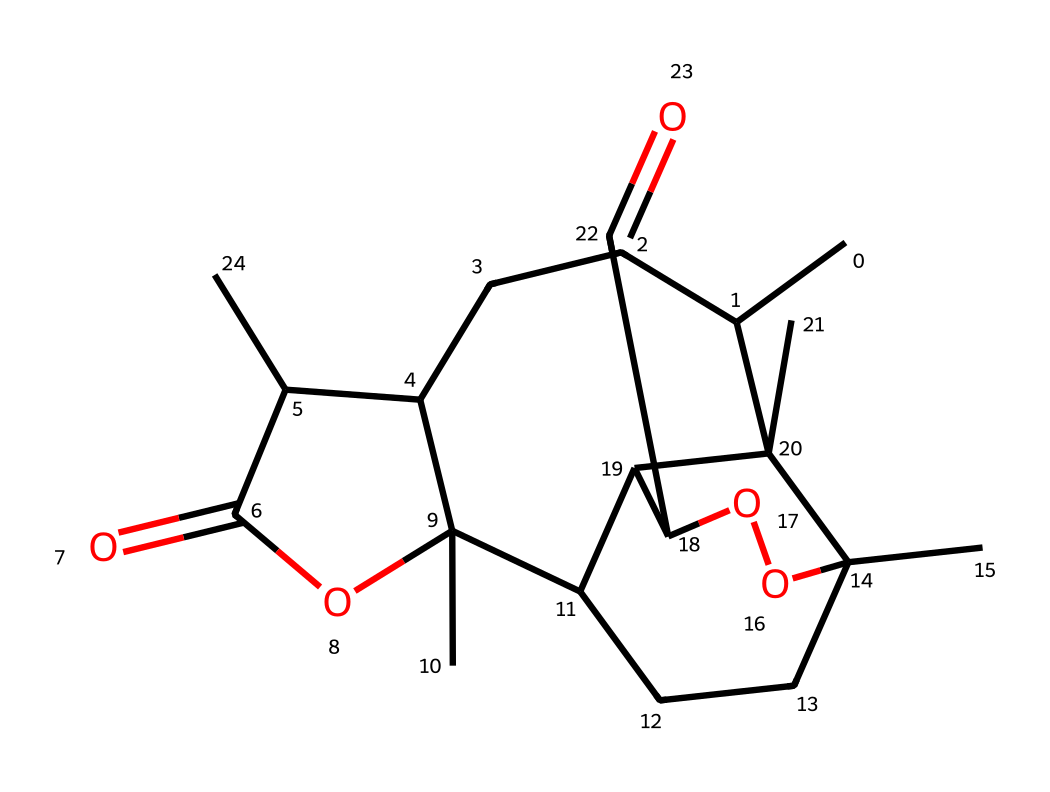What is the molecular formula of artemisinin? By analyzing the SMILES representation, we can determine the number of carbon, hydrogen, oxygen, and other atoms present in the structure. The molecular formula is derived by counting each type of atom explicitly.
Answer: C15H18O5 How many rings are present in the chemical structure of artemisinin? In the SMILES representation, we can identify the ring structures by looking for numbers indicating the start and end of rings. By examining the structure, we find there are four ring structures.
Answer: 4 Which functional group is prominent in artemisinin? Review the SMILES structure for specific arrangements characteristic of functional groups. In this case, we can identify esters and ketones as part of the structure by locating the carbonyl (C=O) and ester linkages (C(=O)OC).
Answer: ester and ketone What type of compound is artemisinin? The analysis of the molecule shows it has properties typical of sesquiterpenes, which are a subclass of terpenes. Considering the cyclic nature and the presence of multiple carbons with specific functional groups, artemisinin can be classified accordingly.
Answer: sesquiterpene What is the significance of the lactone in artemisinin? The presence of a lactone (cyclic ester) is significant because it contributes to the molecule's stability and biological activity, particularly its effectiveness as an antimalarial agent. This structural feature enables important interactions with biological targets.
Answer: stabilizes activity What is the major biological activity of artemisinin? The molecular structure correlates with its antimalarial properties, which is due to the presence of a peroxide bridge (the -O-O- part) that is crucial for its activity against malaria-causing parasites by generating reactive oxygen species.
Answer: antimalarial How does the oxygen in artemisinin contribute to its function? The oxygen atoms play a critical role in reactivity, particularly the peroxide group, which is responsible for generating free radicals that interact with the malaria parasites. This mechanism makes artemisinin an effective treatment.
Answer: free radical generation 